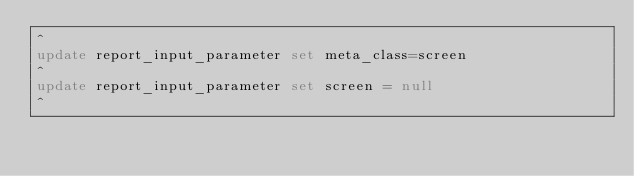<code> <loc_0><loc_0><loc_500><loc_500><_SQL_>^
update report_input_parameter set meta_class=screen
^
update report_input_parameter set screen = null
^
</code> 